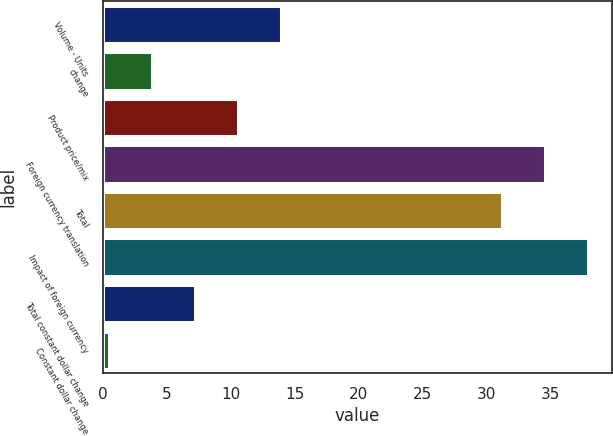<chart> <loc_0><loc_0><loc_500><loc_500><bar_chart><fcel>Volume - Units<fcel>change<fcel>Product price/mix<fcel>Foreign currency translation<fcel>Total<fcel>Impact of foreign currency<fcel>Total constant dollar change<fcel>Constant dollar change<nl><fcel>13.94<fcel>3.86<fcel>10.58<fcel>34.56<fcel>31.2<fcel>37.92<fcel>7.22<fcel>0.5<nl></chart> 